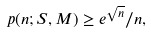Convert formula to latex. <formula><loc_0><loc_0><loc_500><loc_500>p ( n ; S , M ) \geq e ^ { \sqrt { n } } / n ,</formula> 